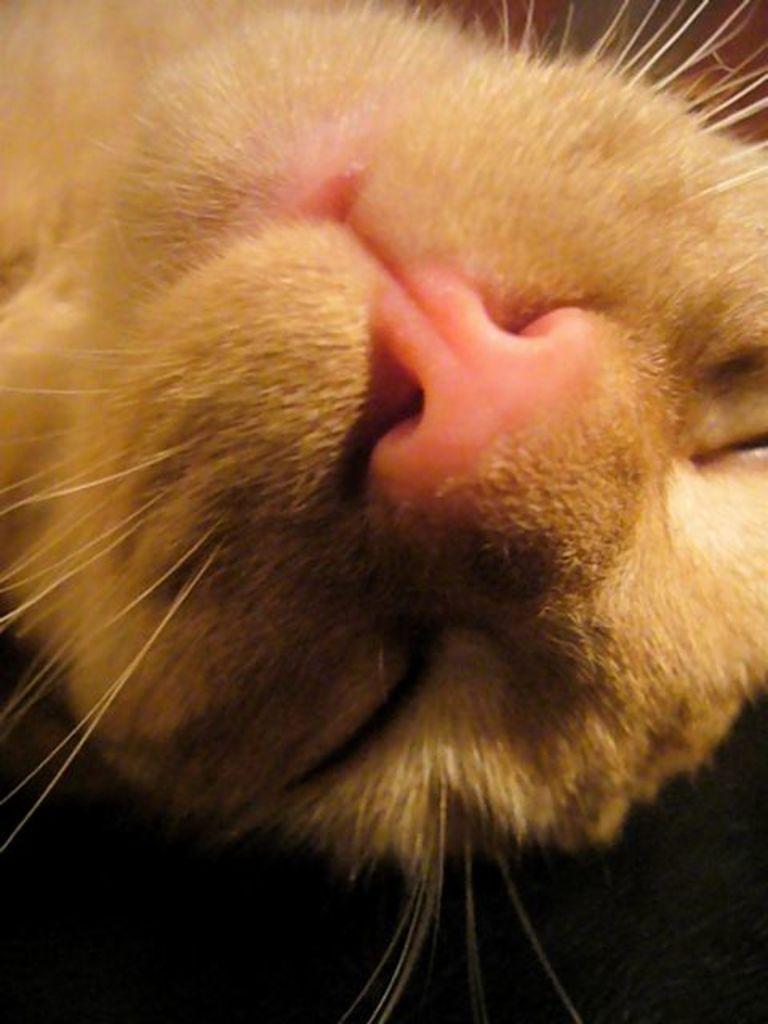In one or two sentences, can you explain what this image depicts? In the center of the image there is a cat face. 